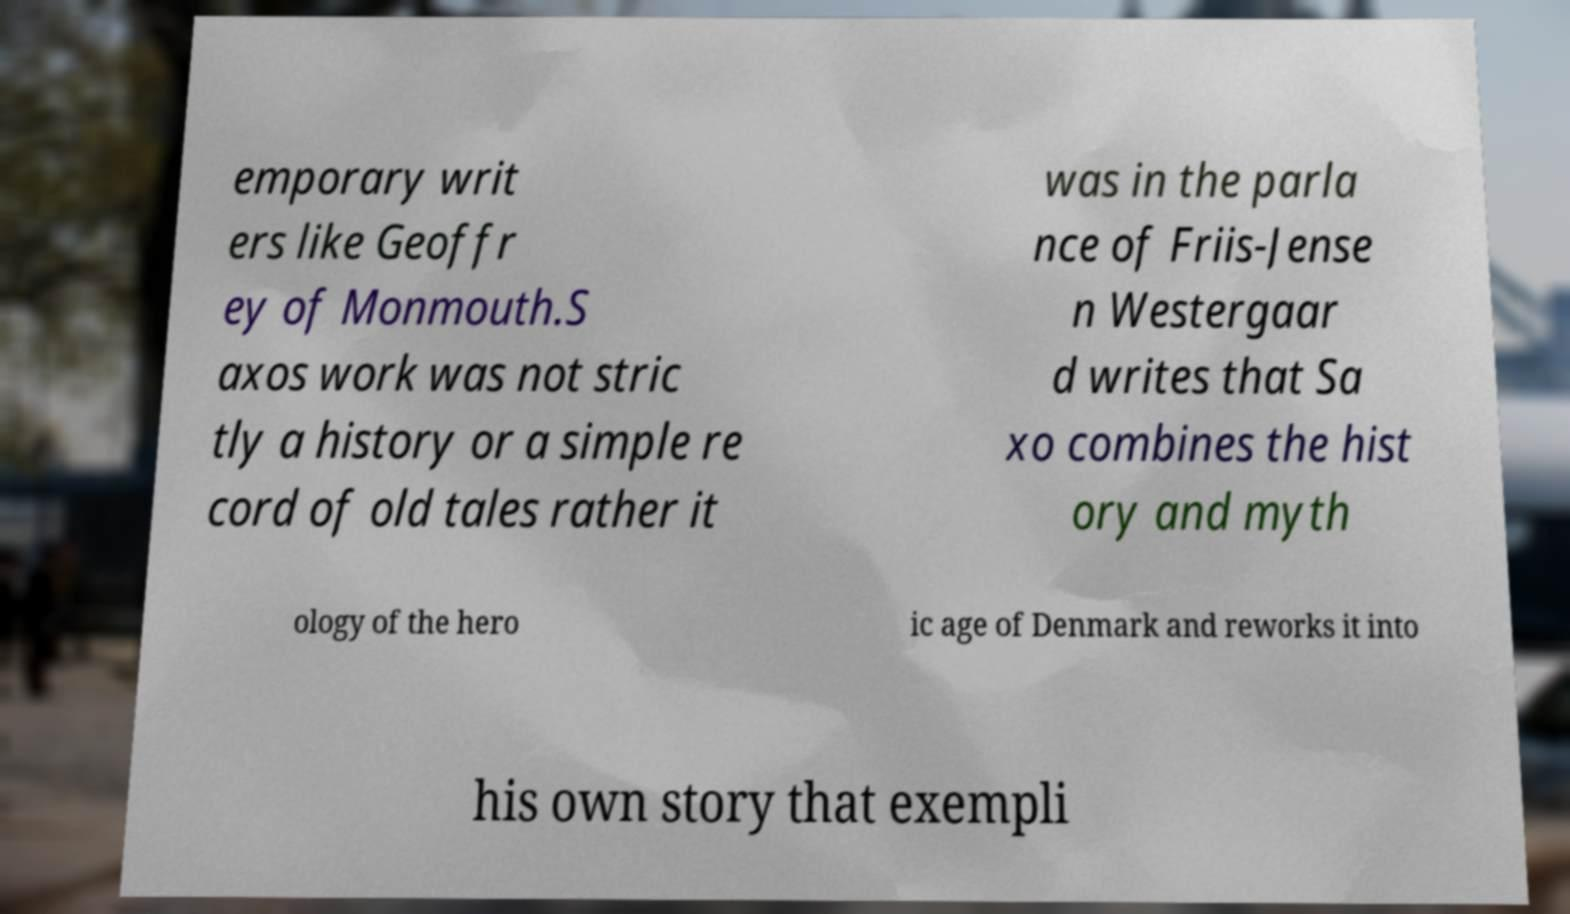Can you read and provide the text displayed in the image?This photo seems to have some interesting text. Can you extract and type it out for me? emporary writ ers like Geoffr ey of Monmouth.S axos work was not stric tly a history or a simple re cord of old tales rather it was in the parla nce of Friis-Jense n Westergaar d writes that Sa xo combines the hist ory and myth ology of the hero ic age of Denmark and reworks it into his own story that exempli 